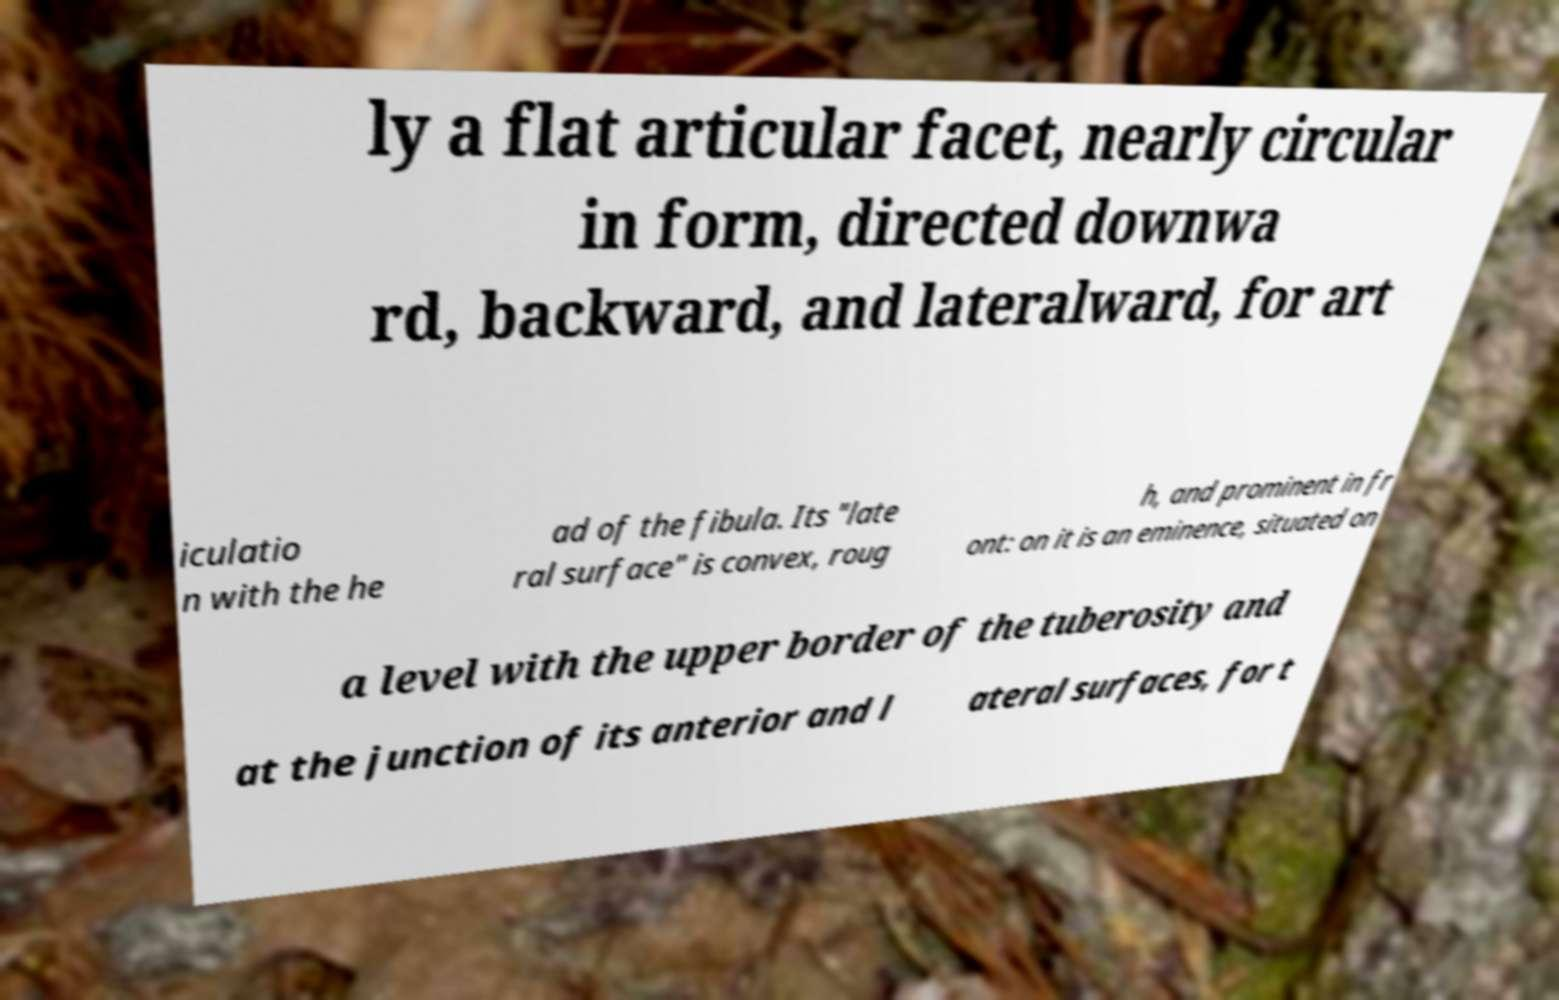Can you read and provide the text displayed in the image?This photo seems to have some interesting text. Can you extract and type it out for me? ly a flat articular facet, nearly circular in form, directed downwa rd, backward, and lateralward, for art iculatio n with the he ad of the fibula. Its "late ral surface" is convex, roug h, and prominent in fr ont: on it is an eminence, situated on a level with the upper border of the tuberosity and at the junction of its anterior and l ateral surfaces, for t 